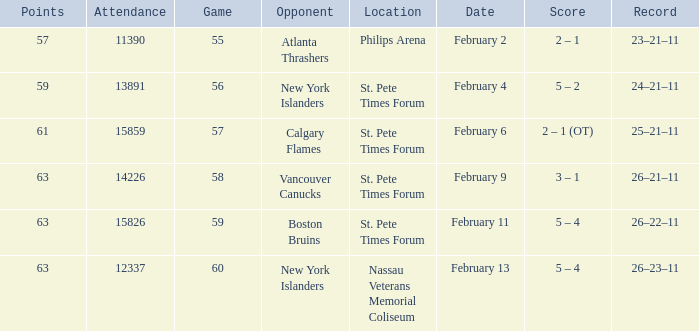What scores happened on February 9? 3 – 1. 